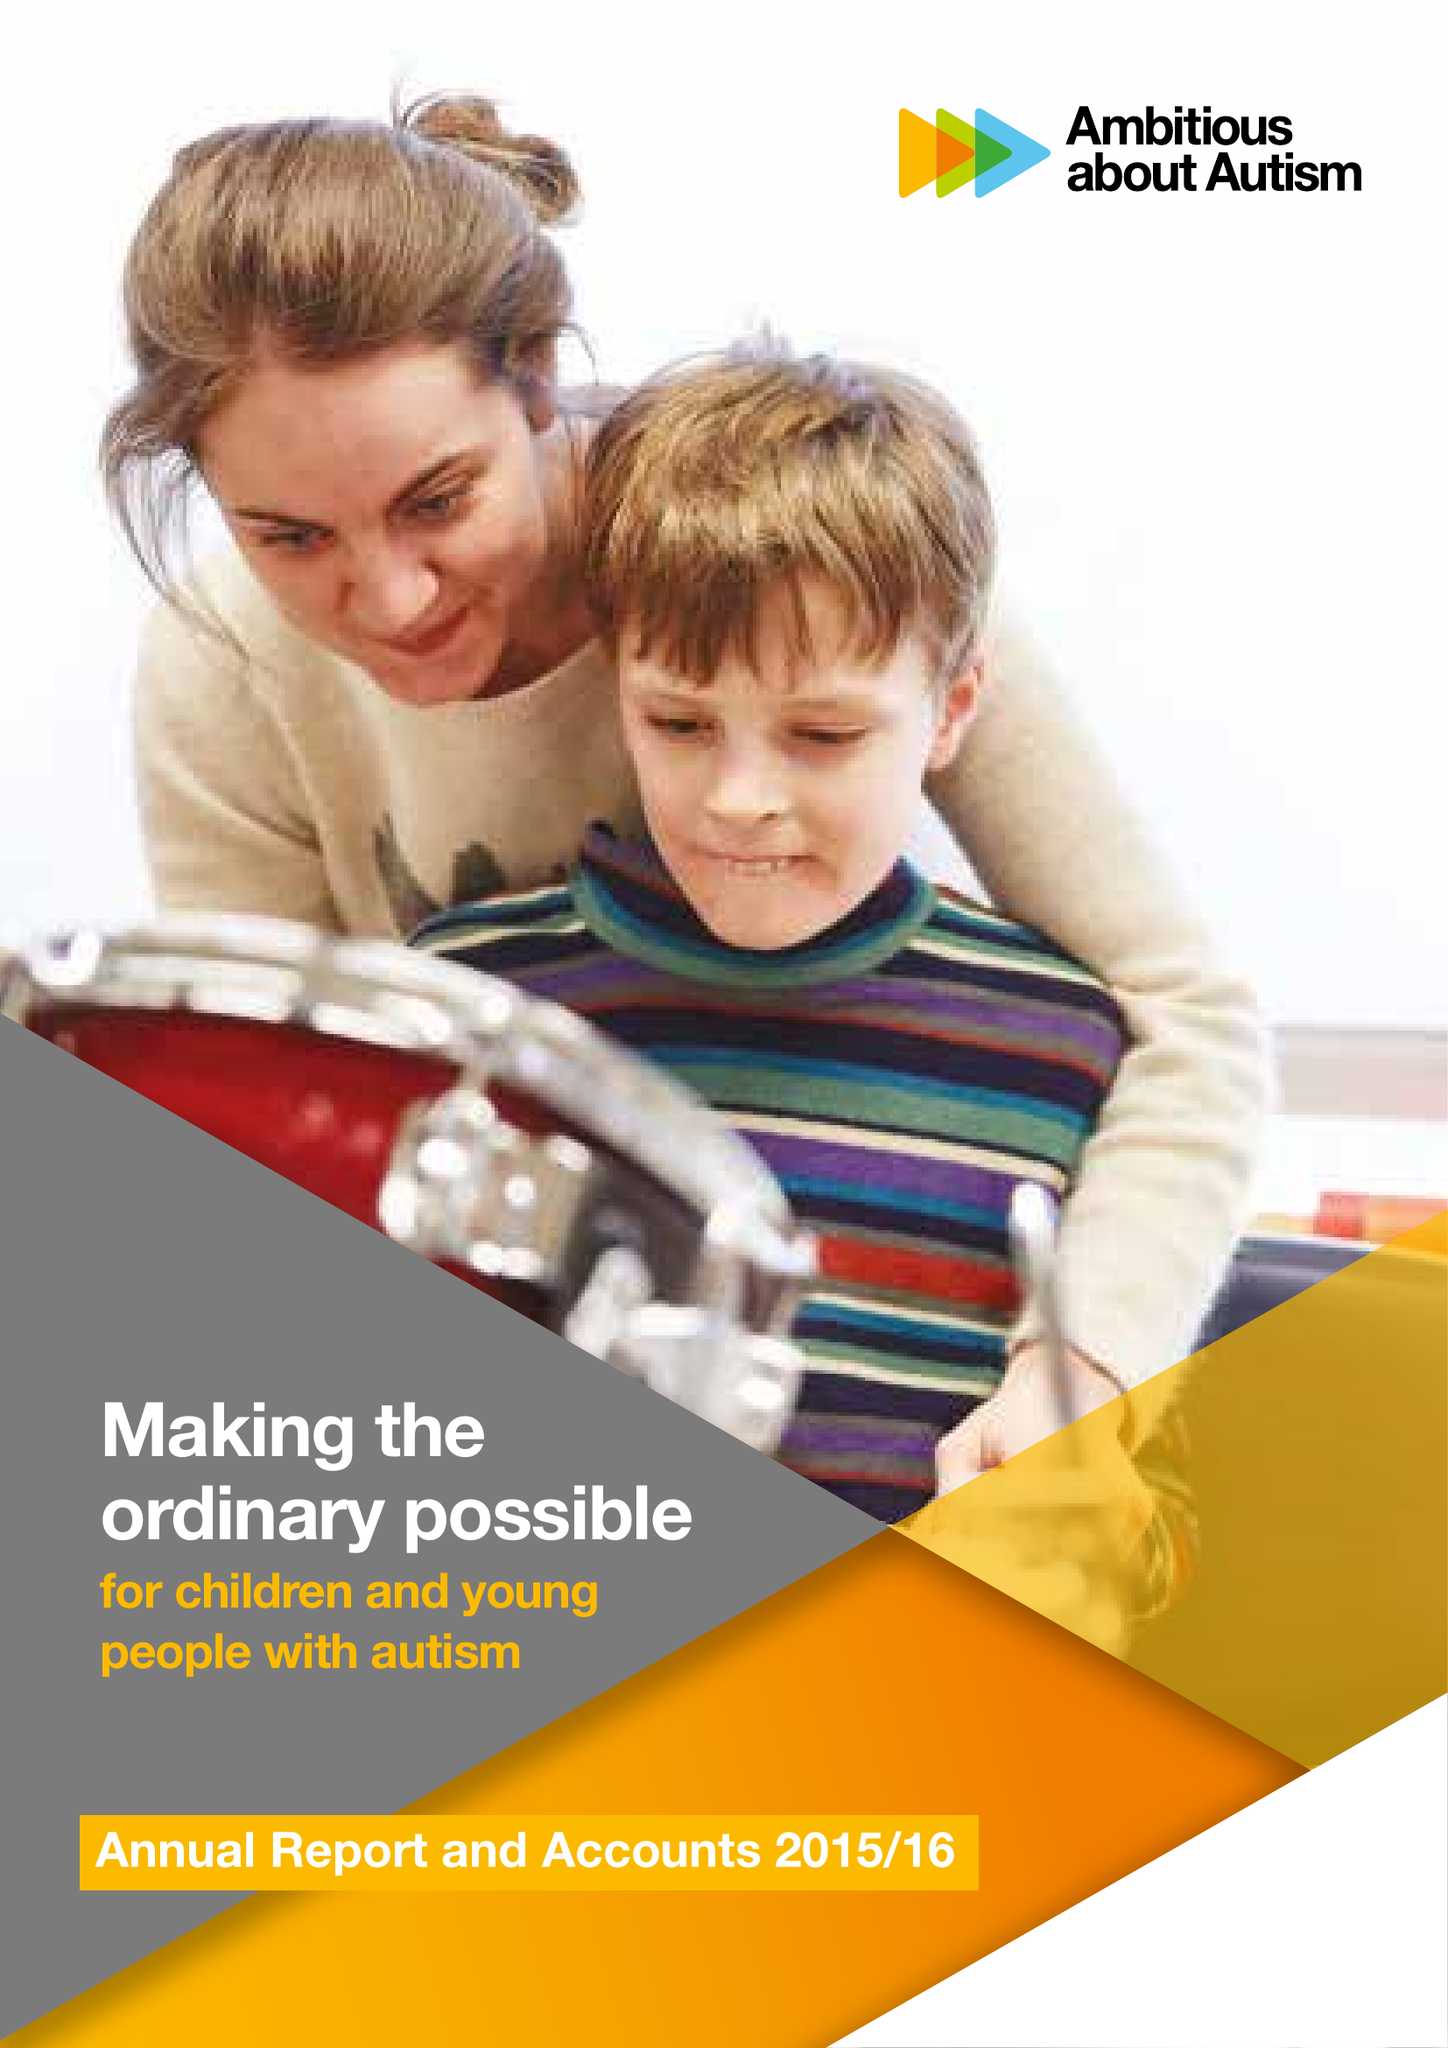What is the value for the report_date?
Answer the question using a single word or phrase. 2016-03-31 